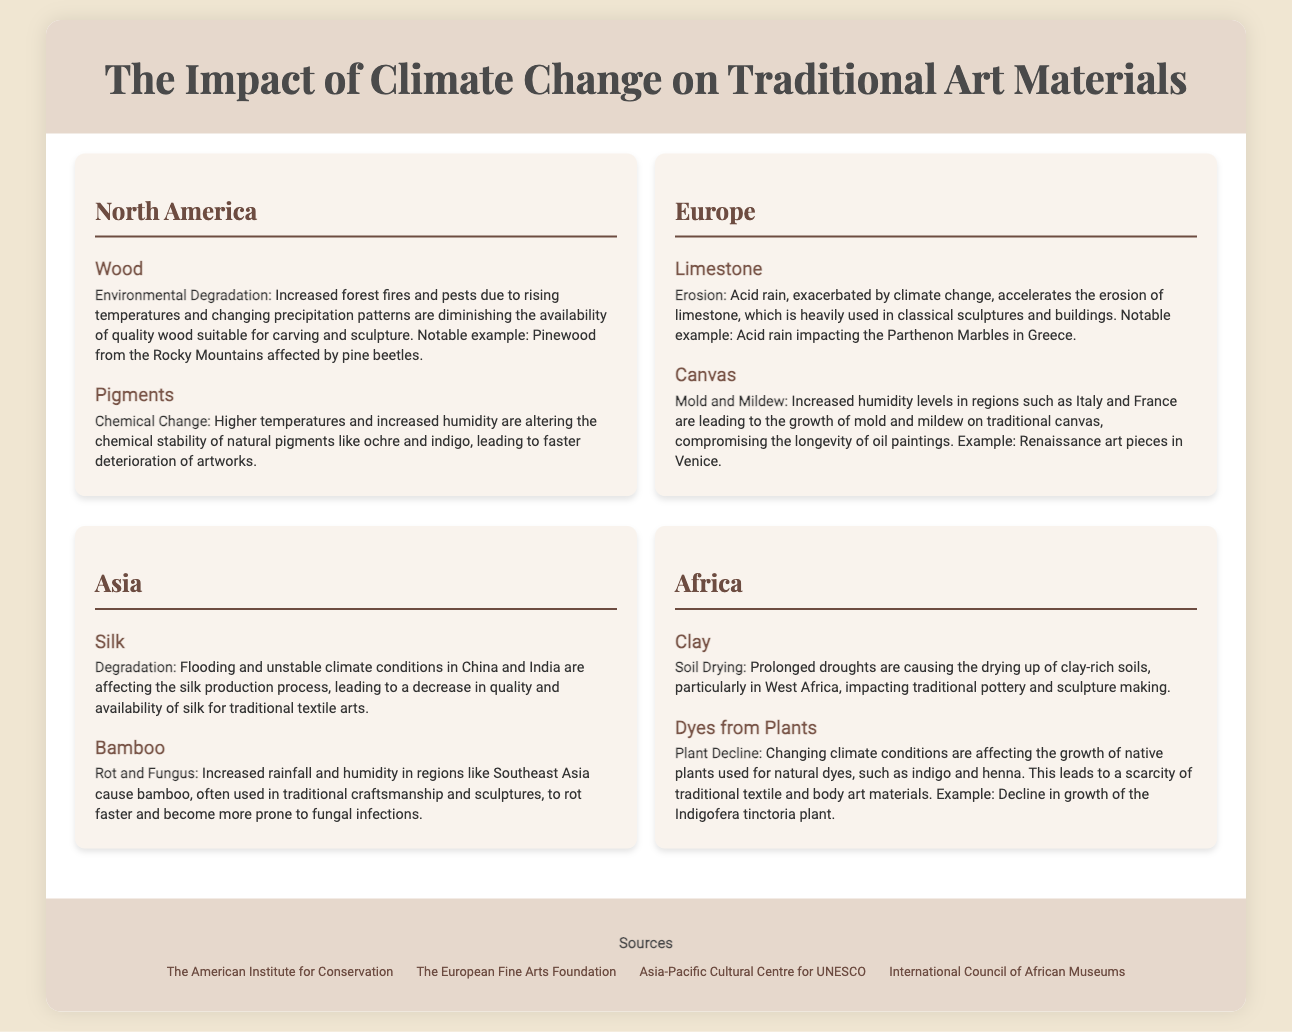What traditional art material is impacted in North America? In North America, wood and pigments are highlighted as traditional art materials affected by climate change.
Answer: Wood, Pigments What is causing the erosion of limestone in Europe? The document states that acid rain, exacerbated by climate change, accelerates the erosion of limestone.
Answer: Acid rain Which traditional art material in Asia is affected by flooding? The document mentions that silk production is impacted by flooding and unstable climate conditions in Asia.
Answer: Silk What plant's decline affects traditional dyes in Africa? The decline in growth of the Indigofera tinctoria plant is specifically mentioned as impacting traditional dyes.
Answer: Indigofera tinctoria What is one impact of climate change on clay in Africa? The document notes that prolonged droughts are causing the drying up of clay-rich soils, impacting traditional pottery and sculpture making.
Answer: Soil drying How does increased humidity affect canvas in Europe? Increased humidity leads to the growth of mold and mildew on traditional canvas, compromising the longevity of oil paintings.
Answer: Mold and mildew What is the notable effect on bamboo in Asia? The document states that increased rainfall and humidity cause bamboo to rot faster and become more prone to fungal infections.
Answer: Rot and fungus What notable example is given for the impact on limestone? The document provides the Parthenon Marbles in Greece as a notable example affected by acid rain.
Answer: Parthenon Marbles Which two regions mention the impact of climate on art materials? The document discusses the impacts on traditional art materials in North America, Europe, Asia, and Africa, highlighting various examples.
Answer: North America, Europe, Asia, Africa 